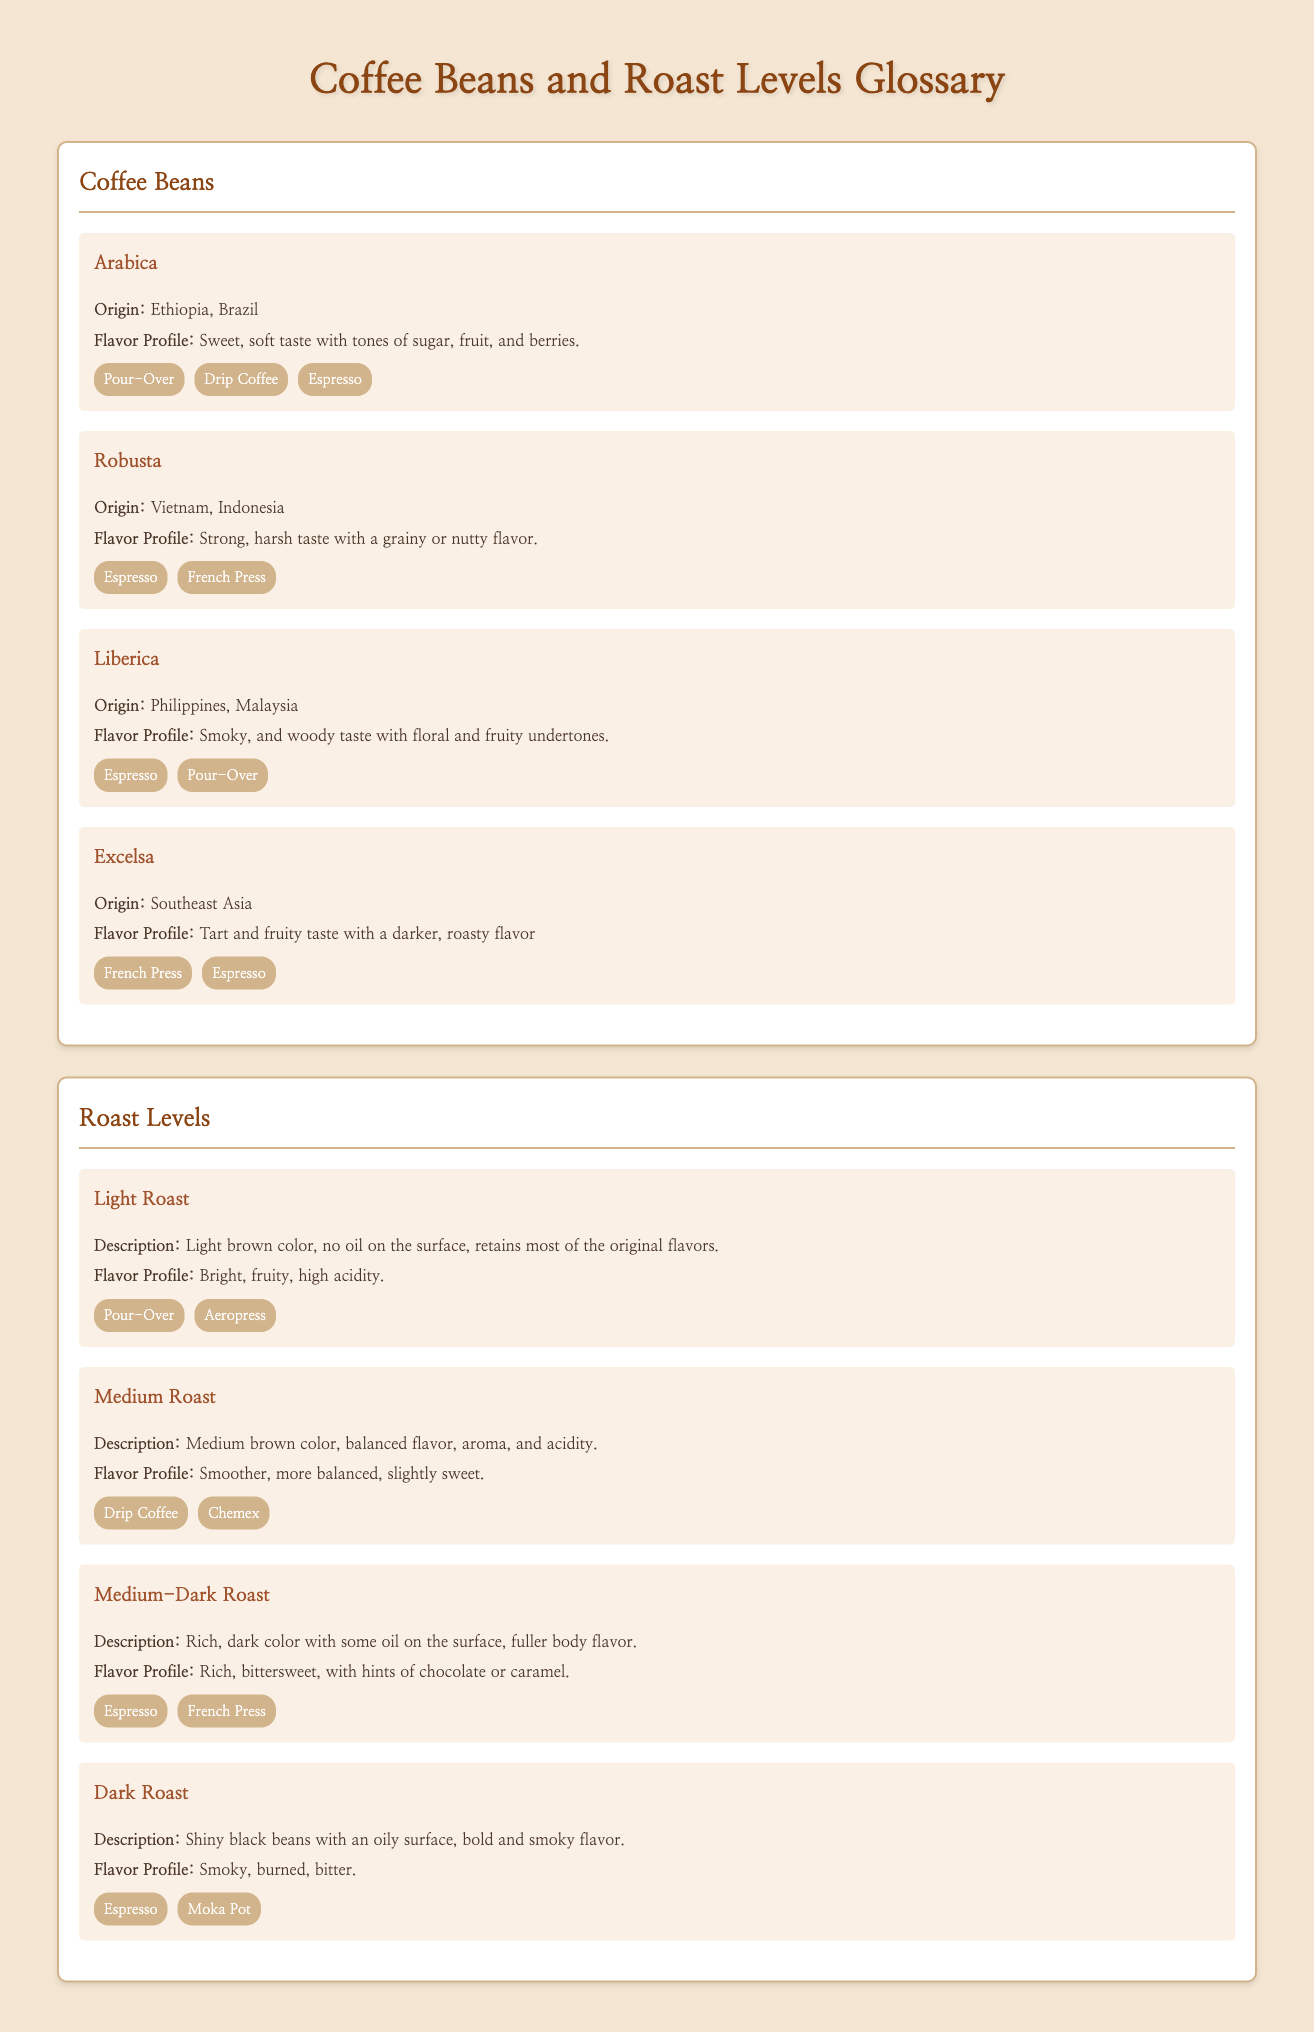What is the origin of Arabica beans? The origin of Arabica beans is mentioned as Ethiopia and Brazil in the document.
Answer: Ethiopia, Brazil What flavor profile is associated with Robusta? The flavor profile of Robusta is described in the document as strong, harsh, with a grainy or nutty flavor.
Answer: Strong, harsh, grainy or nutty Which brewing method is best for Light Roast? The document lists the suitable brewing methods for Light Roast, including Pour-Over and Aeropress.
Answer: Pour-Over How does Medium-Dark Roast compare to Medium Roast in terms of flavor? The document describes Medium-Dark Roast as having a richer, bittersweet flavor compared to the smoother, more balanced flavor of Medium Roast.
Answer: Rich, bittersweet What color are Dark Roast beans? The document specifies that Dark Roast beans are described as shiny black with an oily surface.
Answer: Shiny black What is the primary characteristic of Liberica beans? The primary characteristic of Liberica beans mentioned in the document is the smoky and woody taste with floral and fruity undertones.
Answer: Smoky, woody How many roast levels are listed in the document? The document outlines a total of four roast levels: Light Roast, Medium Roast, Medium-Dark Roast, and Dark Roast.
Answer: Four Which flavor profile has the highest acidity? The document states that the flavor profile for Light Roast is bright and fruity, with high acidity.
Answer: Bright, fruity, high acidity 